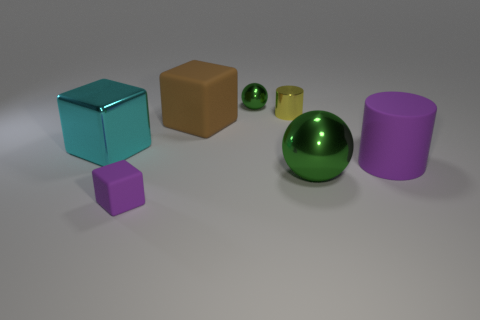Are there fewer big purple matte cylinders on the left side of the large cyan metal object than tiny purple objects?
Keep it short and to the point. Yes. What number of cubes are there?
Your answer should be compact. 3. How many big purple cylinders have the same material as the tiny green ball?
Provide a short and direct response. 0. What number of objects are objects that are right of the small purple matte block or blue cylinders?
Make the answer very short. 5. Are there fewer cyan metal cubes that are in front of the big shiny block than cylinders that are on the left side of the large green thing?
Your answer should be very brief. Yes. There is a big metal cube; are there any small things behind it?
Ensure brevity in your answer.  Yes. How many things are large rubber things that are on the right side of the small green shiny thing or metallic objects that are left of the yellow metal cylinder?
Your answer should be very brief. 3. How many other tiny metal balls are the same color as the small shiny sphere?
Your answer should be compact. 0. What is the color of the large metal object that is the same shape as the tiny purple matte thing?
Make the answer very short. Cyan. There is a big object that is behind the large cylinder and on the right side of the large cyan block; what is its shape?
Your answer should be very brief. Cube. 